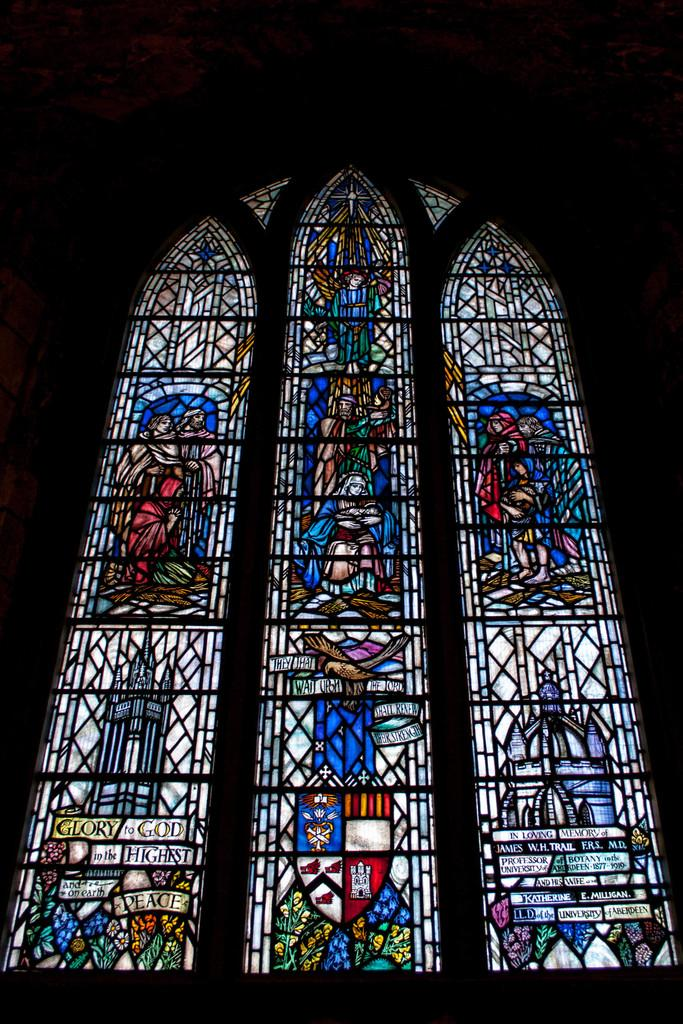What type of door is visible in the image? There is a glass door in the image. What is depicted on the glass door? The glass door has a glass painting on it. What elements are included in the glass painting? The painting includes buildings, persons, letters, and flowers. How would you describe the overall lighting in the image? The background of the image appears dark. How many spiders are crawling on the glass door in the image? There are no spiders visible on the glass door in the image. What type of powder is used to create the painting on the glass door? The painting on the glass door is a glass painting, and there is no mention of powder being used in its creation. 